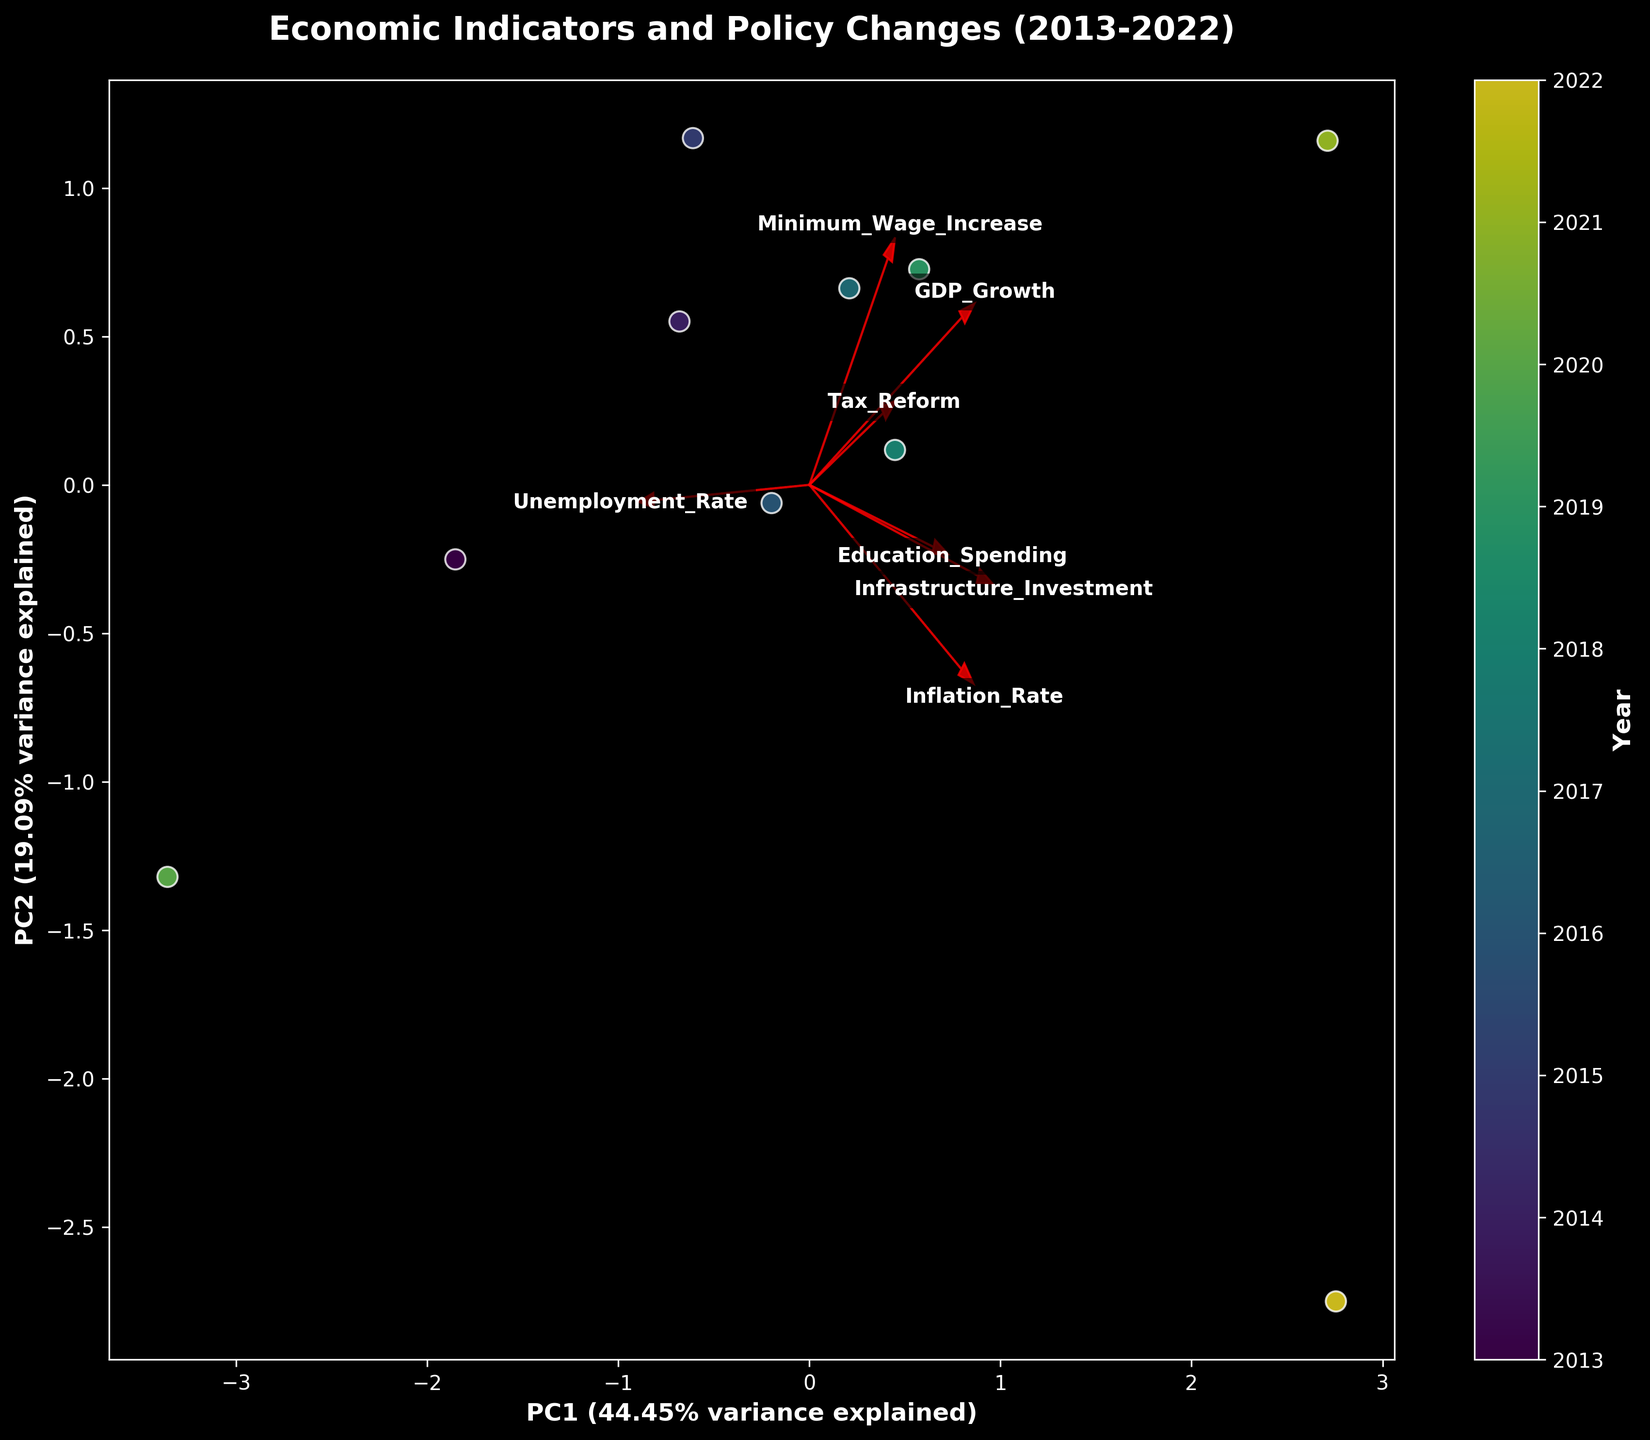What does the title of the plot indicate? The title of the plot, "Economic Indicators and Policy Changes (2013-2022)," implies that the biplot represents the relationship between various economic indicators and policy changes within the time frame from 2013 to 2022.
Answer: Economic Indicators and Policy Changes (2013-2022) How many data points are plotted in the biplot? Each year from 2013 to 2022 is represented as a data point in the biplot. Therefore, there are 10 data points plotted.
Answer: 10 Which two economic indicators have the most closely aligned vectors? By observing the directions of the arrows (vectors) in the plot, "Infrastructure_Investment" and "Education_Spending" have the most closely aligned vectors as their arrows point in nearly the same direction.
Answer: Infrastructure_Investment and Education_Spending What is the direction of the "GDP_Growth" vector relative to the other economic indicators? The "GDP_Growth" vector points more toward the right, indicating that it has a strong positive correlation with PC1 compared to other economic indicators. This suggests that GDP growth is a significant contributor to the variance captured by PC1.
Answer: Stronger positive along PC1 What is the variance explained by PC1 and PC2? The labels on the axes state the variance explained by PC1 and PC2. PC1 explains 49.79% of the variance, and PC2 explains 30.89% of the variance. Together, they explain 49.79% + 30.89% = 80.68% of the variance.
Answer: PC1: 49.79%, PC2: 30.89% Which year shows the highest correlation with "Minimum_Wage_Increase"? By looking at the proximity of the data points relative to the "Minimum_Wage_Increase" vector, 2021 is the year that is closest to this vector, indicating the highest correlation.
Answer: 2021 How do "Unemployment_Rate" and "Inflation_Rate" relate to PC1 and PC2? By examining the plot, both "Unemployment_Rate" and "Inflation_Rate" vectors are directed opposite to the "GDP_Growth" vector. This suggests that they have a negative correlation with PC1. "Inflation_Rate" has a slightly different angle, indicating it's also influenced by PC2.
Answer: Negative to PC1, different impact on PC2 Which policy change indicator is least aligned with GDP growth? The vector for "GDP_Growth" points in a different direction from "Tax_Reform," indicating a lack of correlation or even a negative correlation.
Answer: Tax_Reform Is there any visible pattern in the correlation between the years and one of the axes (PC1 or PC2)? Observing the plot, the years are color-mapped. Later years (e.g., 2021, 2022) seem to be more associated with higher values on the PC1 axis, indicating economic indicators with higher variance in recent years.
Answer: Later years correlate with higher PC1 